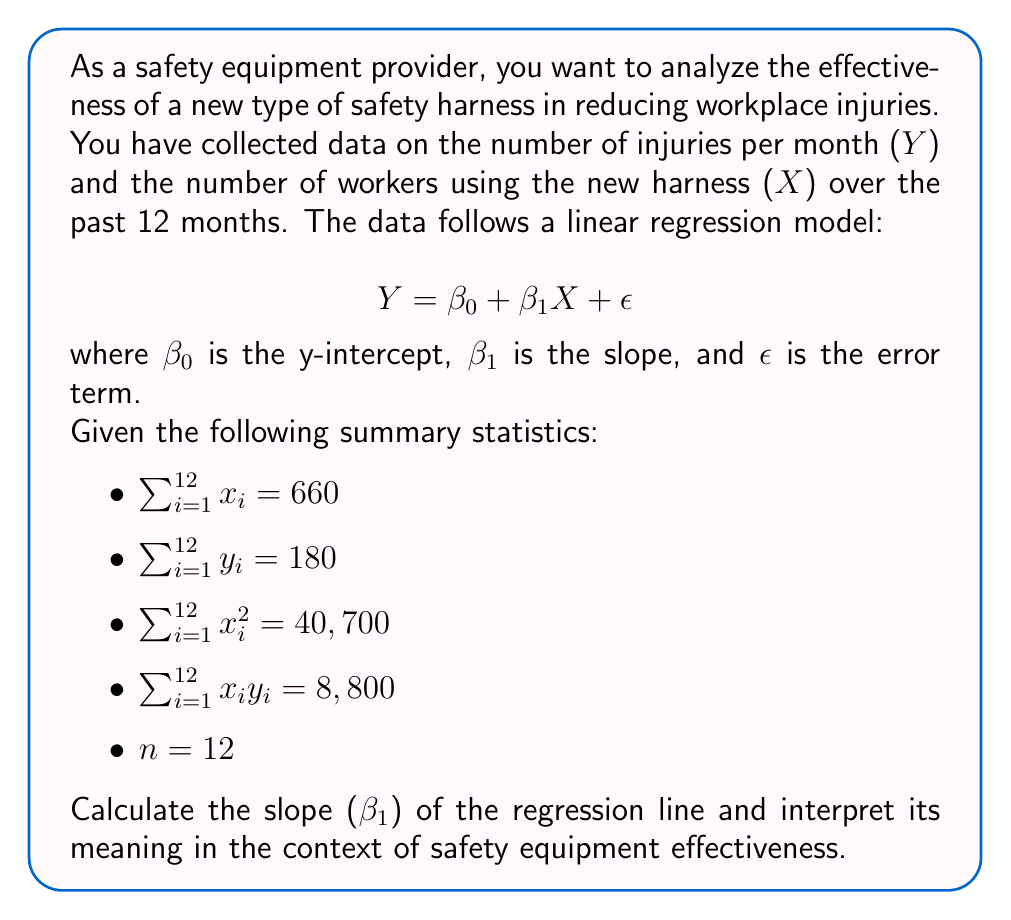Can you solve this math problem? To calculate the slope ($\beta_1$) of the regression line, we'll use the formula:

$$\beta_1 = \frac{n\sum x_iy_i - \sum x_i \sum y_i}{n\sum x_i^2 - (\sum x_i)^2}$$

Let's substitute the given values:

$$\beta_1 = \frac{12(8,800) - 660(180)}{12(40,700) - 660^2}$$

$$\beta_1 = \frac{105,600 - 118,800}{488,400 - 435,600}$$

$$\beta_1 = \frac{-13,200}{52,800}$$

$$\beta_1 = -0.25$$

Interpretation:
The slope $\beta_1 = -0.25$ represents the change in the number of injuries (Y) for each additional worker using the new safety harness (X). 

In this case, for each additional worker using the new safety harness, we expect the number of injuries per month to decrease by 0.25 on average. This negative slope indicates that the new safety harness is effective in reducing workplace injuries.

To put it in context:
- If 10 more workers use the new harness, we would expect a decrease of 2.5 injuries per month (10 * -0.25 = -2.5).
- If 100 more workers use the new harness, we would expect a decrease of 25 injuries per month (100 * -0.25 = -25).

This analysis suggests that the new safety harness is an effective measure for improving workplace safety, as increased usage is associated with a decrease in injuries.
Answer: $\beta_1 = -0.25$

The slope of -0.25 indicates that for each additional worker using the new safety harness, the number of injuries per month is expected to decrease by 0.25 on average, demonstrating the effectiveness of the new safety equipment in reducing workplace injuries. 